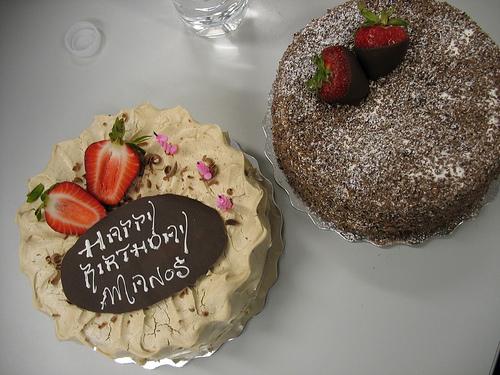Is that fresh fruit?
Give a very brief answer. Yes. What fruit is present in the image?
Concise answer only. Strawberry. Can you see a bottle cap?
Quick response, please. Yes. 